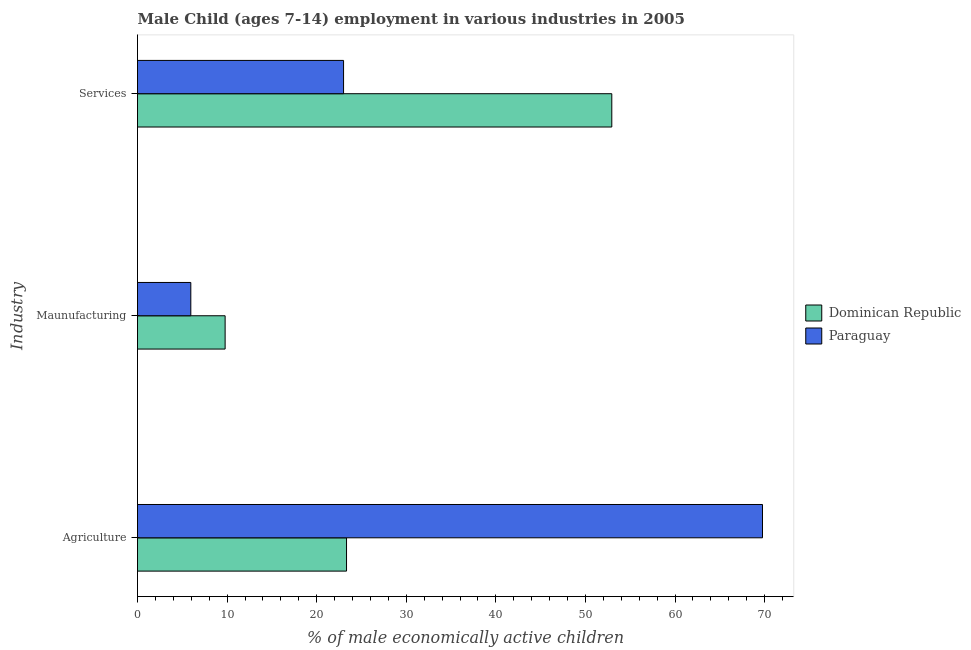How many different coloured bars are there?
Offer a very short reply. 2. How many groups of bars are there?
Give a very brief answer. 3. Are the number of bars per tick equal to the number of legend labels?
Offer a terse response. Yes. How many bars are there on the 2nd tick from the top?
Ensure brevity in your answer.  2. How many bars are there on the 1st tick from the bottom?
Make the answer very short. 2. What is the label of the 3rd group of bars from the top?
Your response must be concise. Agriculture. What is the percentage of economically active children in agriculture in Paraguay?
Make the answer very short. 69.76. Across all countries, what is the maximum percentage of economically active children in agriculture?
Make the answer very short. 69.76. Across all countries, what is the minimum percentage of economically active children in manufacturing?
Your answer should be very brief. 5.95. In which country was the percentage of economically active children in manufacturing maximum?
Provide a succinct answer. Dominican Republic. In which country was the percentage of economically active children in agriculture minimum?
Keep it short and to the point. Dominican Republic. What is the total percentage of economically active children in services in the graph?
Keep it short and to the point. 75.94. What is the difference between the percentage of economically active children in services in Dominican Republic and that in Paraguay?
Keep it short and to the point. 29.94. What is the difference between the percentage of economically active children in agriculture in Dominican Republic and the percentage of economically active children in manufacturing in Paraguay?
Give a very brief answer. 17.38. What is the average percentage of economically active children in agriculture per country?
Keep it short and to the point. 46.55. What is the difference between the percentage of economically active children in manufacturing and percentage of economically active children in services in Paraguay?
Your answer should be compact. -17.05. What is the ratio of the percentage of economically active children in manufacturing in Paraguay to that in Dominican Republic?
Offer a very short reply. 0.61. Is the difference between the percentage of economically active children in manufacturing in Paraguay and Dominican Republic greater than the difference between the percentage of economically active children in agriculture in Paraguay and Dominican Republic?
Give a very brief answer. No. What is the difference between the highest and the second highest percentage of economically active children in services?
Ensure brevity in your answer.  29.94. What is the difference between the highest and the lowest percentage of economically active children in services?
Provide a short and direct response. 29.94. In how many countries, is the percentage of economically active children in agriculture greater than the average percentage of economically active children in agriculture taken over all countries?
Offer a very short reply. 1. Is the sum of the percentage of economically active children in agriculture in Paraguay and Dominican Republic greater than the maximum percentage of economically active children in services across all countries?
Your answer should be compact. Yes. What does the 1st bar from the top in Agriculture represents?
Give a very brief answer. Paraguay. What does the 2nd bar from the bottom in Services represents?
Provide a short and direct response. Paraguay. Is it the case that in every country, the sum of the percentage of economically active children in agriculture and percentage of economically active children in manufacturing is greater than the percentage of economically active children in services?
Keep it short and to the point. No. Are all the bars in the graph horizontal?
Your answer should be very brief. Yes. Where does the legend appear in the graph?
Keep it short and to the point. Center right. How are the legend labels stacked?
Your answer should be very brief. Vertical. What is the title of the graph?
Give a very brief answer. Male Child (ages 7-14) employment in various industries in 2005. What is the label or title of the X-axis?
Your response must be concise. % of male economically active children. What is the label or title of the Y-axis?
Ensure brevity in your answer.  Industry. What is the % of male economically active children of Dominican Republic in Agriculture?
Provide a short and direct response. 23.33. What is the % of male economically active children of Paraguay in Agriculture?
Ensure brevity in your answer.  69.76. What is the % of male economically active children in Dominican Republic in Maunufacturing?
Your response must be concise. 9.78. What is the % of male economically active children in Paraguay in Maunufacturing?
Offer a terse response. 5.95. What is the % of male economically active children of Dominican Republic in Services?
Keep it short and to the point. 52.94. Across all Industry, what is the maximum % of male economically active children in Dominican Republic?
Ensure brevity in your answer.  52.94. Across all Industry, what is the maximum % of male economically active children in Paraguay?
Keep it short and to the point. 69.76. Across all Industry, what is the minimum % of male economically active children in Dominican Republic?
Ensure brevity in your answer.  9.78. Across all Industry, what is the minimum % of male economically active children in Paraguay?
Your answer should be compact. 5.95. What is the total % of male economically active children in Dominican Republic in the graph?
Provide a succinct answer. 86.05. What is the total % of male economically active children of Paraguay in the graph?
Provide a short and direct response. 98.71. What is the difference between the % of male economically active children in Dominican Republic in Agriculture and that in Maunufacturing?
Ensure brevity in your answer.  13.55. What is the difference between the % of male economically active children of Paraguay in Agriculture and that in Maunufacturing?
Give a very brief answer. 63.81. What is the difference between the % of male economically active children in Dominican Republic in Agriculture and that in Services?
Ensure brevity in your answer.  -29.61. What is the difference between the % of male economically active children of Paraguay in Agriculture and that in Services?
Ensure brevity in your answer.  46.76. What is the difference between the % of male economically active children in Dominican Republic in Maunufacturing and that in Services?
Offer a very short reply. -43.16. What is the difference between the % of male economically active children in Paraguay in Maunufacturing and that in Services?
Make the answer very short. -17.05. What is the difference between the % of male economically active children in Dominican Republic in Agriculture and the % of male economically active children in Paraguay in Maunufacturing?
Your answer should be very brief. 17.38. What is the difference between the % of male economically active children in Dominican Republic in Agriculture and the % of male economically active children in Paraguay in Services?
Your answer should be compact. 0.33. What is the difference between the % of male economically active children in Dominican Republic in Maunufacturing and the % of male economically active children in Paraguay in Services?
Your answer should be compact. -13.22. What is the average % of male economically active children in Dominican Republic per Industry?
Ensure brevity in your answer.  28.68. What is the average % of male economically active children of Paraguay per Industry?
Your answer should be compact. 32.9. What is the difference between the % of male economically active children of Dominican Republic and % of male economically active children of Paraguay in Agriculture?
Offer a very short reply. -46.43. What is the difference between the % of male economically active children of Dominican Republic and % of male economically active children of Paraguay in Maunufacturing?
Offer a terse response. 3.83. What is the difference between the % of male economically active children in Dominican Republic and % of male economically active children in Paraguay in Services?
Keep it short and to the point. 29.94. What is the ratio of the % of male economically active children in Dominican Republic in Agriculture to that in Maunufacturing?
Provide a short and direct response. 2.39. What is the ratio of the % of male economically active children in Paraguay in Agriculture to that in Maunufacturing?
Provide a short and direct response. 11.72. What is the ratio of the % of male economically active children of Dominican Republic in Agriculture to that in Services?
Provide a short and direct response. 0.44. What is the ratio of the % of male economically active children of Paraguay in Agriculture to that in Services?
Give a very brief answer. 3.03. What is the ratio of the % of male economically active children of Dominican Republic in Maunufacturing to that in Services?
Your response must be concise. 0.18. What is the ratio of the % of male economically active children of Paraguay in Maunufacturing to that in Services?
Give a very brief answer. 0.26. What is the difference between the highest and the second highest % of male economically active children in Dominican Republic?
Ensure brevity in your answer.  29.61. What is the difference between the highest and the second highest % of male economically active children in Paraguay?
Ensure brevity in your answer.  46.76. What is the difference between the highest and the lowest % of male economically active children of Dominican Republic?
Provide a succinct answer. 43.16. What is the difference between the highest and the lowest % of male economically active children of Paraguay?
Your answer should be compact. 63.81. 